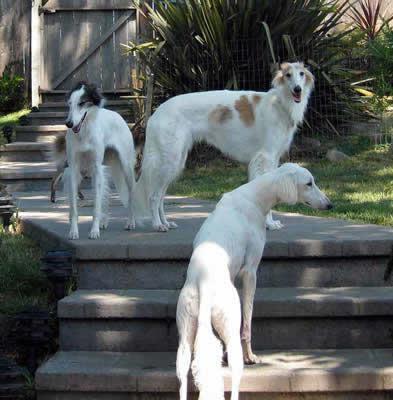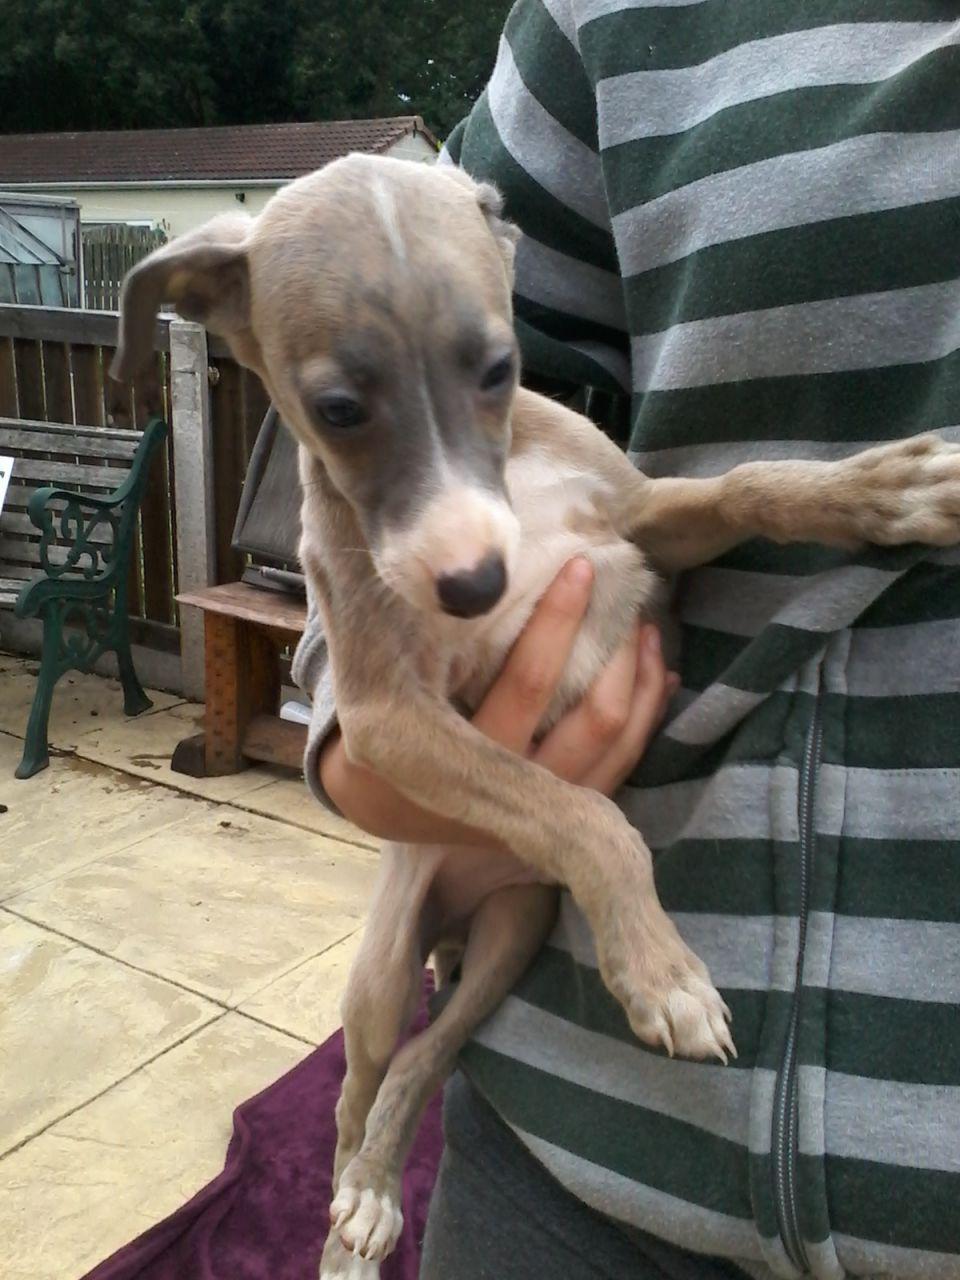The first image is the image on the left, the second image is the image on the right. For the images shown, is this caption "The right image contains no more than one dog." true? Answer yes or no. Yes. The first image is the image on the left, the second image is the image on the right. For the images shown, is this caption "Several hounds are resting together on something manmade, neutral-colored and plush." true? Answer yes or no. No. 